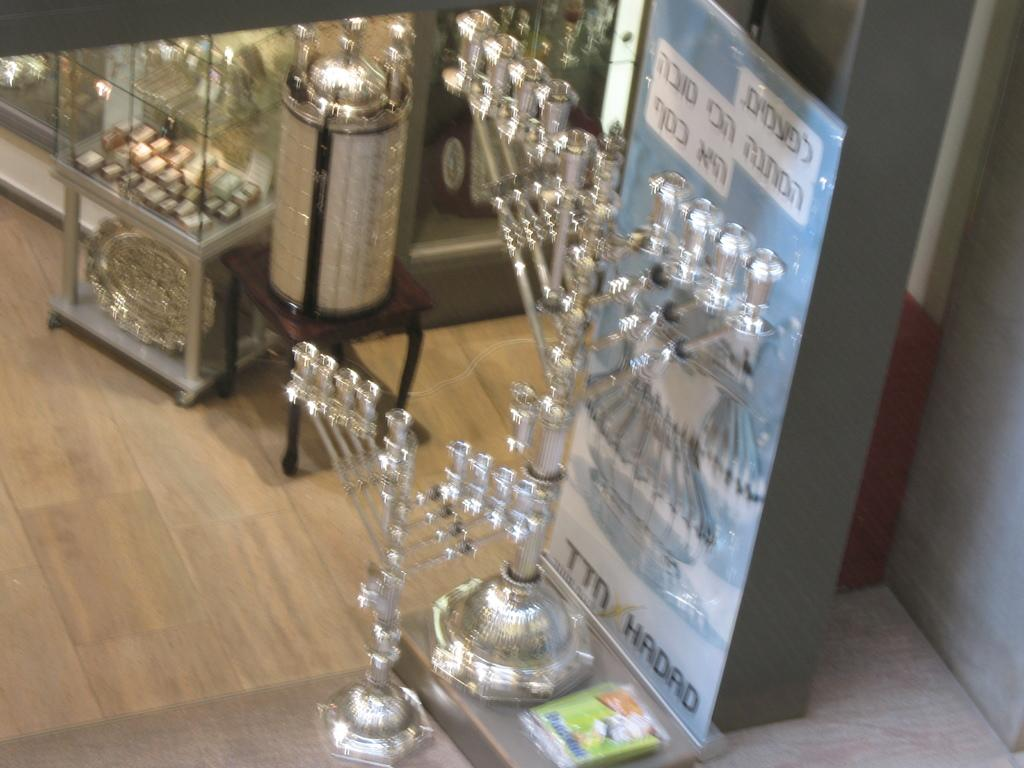What type of furniture is present in the image? There are glass cupboards and a table in the image. What is the material of the floor in the image? The floor appears to be made of wood. What is the large sign in the image called? There is a hoarding in the image. What can be found on the hoarding? Something is written on the hoarding. How many objects can be seen in the image? There are objects in the image, but the exact number is not specified. What type of hammer is being used to make the loaf of bread in the image? There is no hammer or loaf of bread present in the image. How many buttons are on the shirt of the person in the image? There is no person or shirt with buttons in the image. 